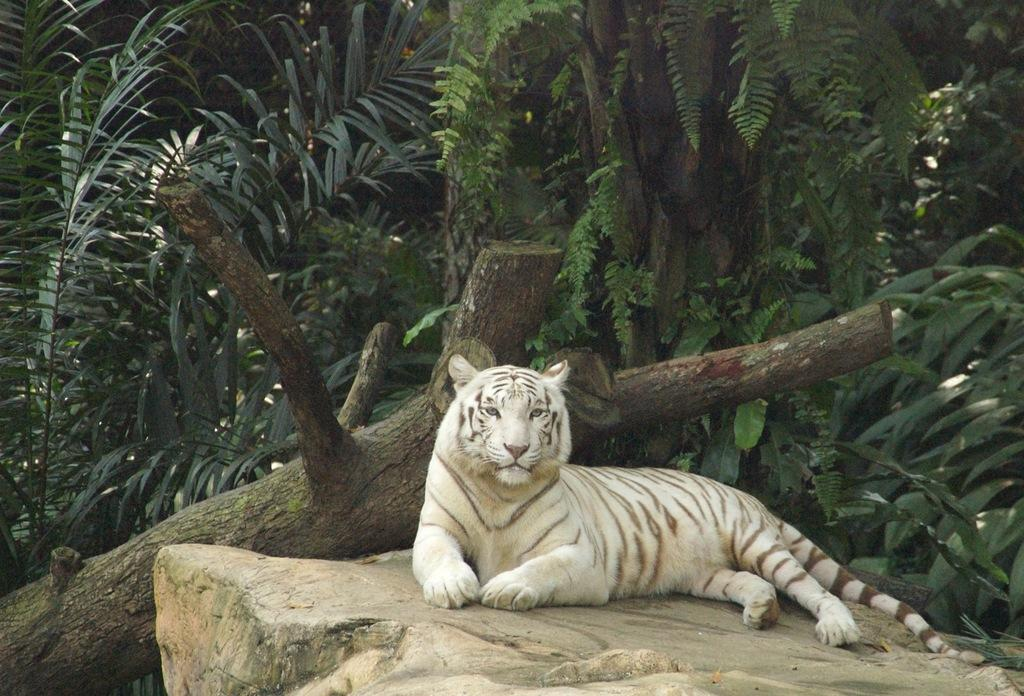What type of animal is in the image? There is a white tiger in the image. Where is the white tiger located? The white tiger is on a rock. What can be seen in the background of the image? There is a tree trunk, plants, and trees in the background of the image. What type of veil is draped over the white tiger in the image? There is no veil present in the image; the white tiger is not wearing or interacting with any veil. 